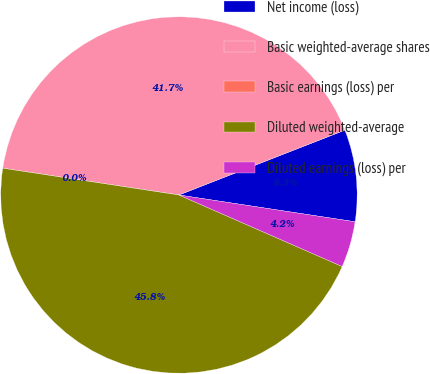Convert chart to OTSL. <chart><loc_0><loc_0><loc_500><loc_500><pie_chart><fcel>Net income (loss)<fcel>Basic weighted-average shares<fcel>Basic earnings (loss) per<fcel>Diluted weighted-average<fcel>Diluted earnings (loss) per<nl><fcel>8.33%<fcel>41.67%<fcel>0.0%<fcel>45.83%<fcel>4.17%<nl></chart> 